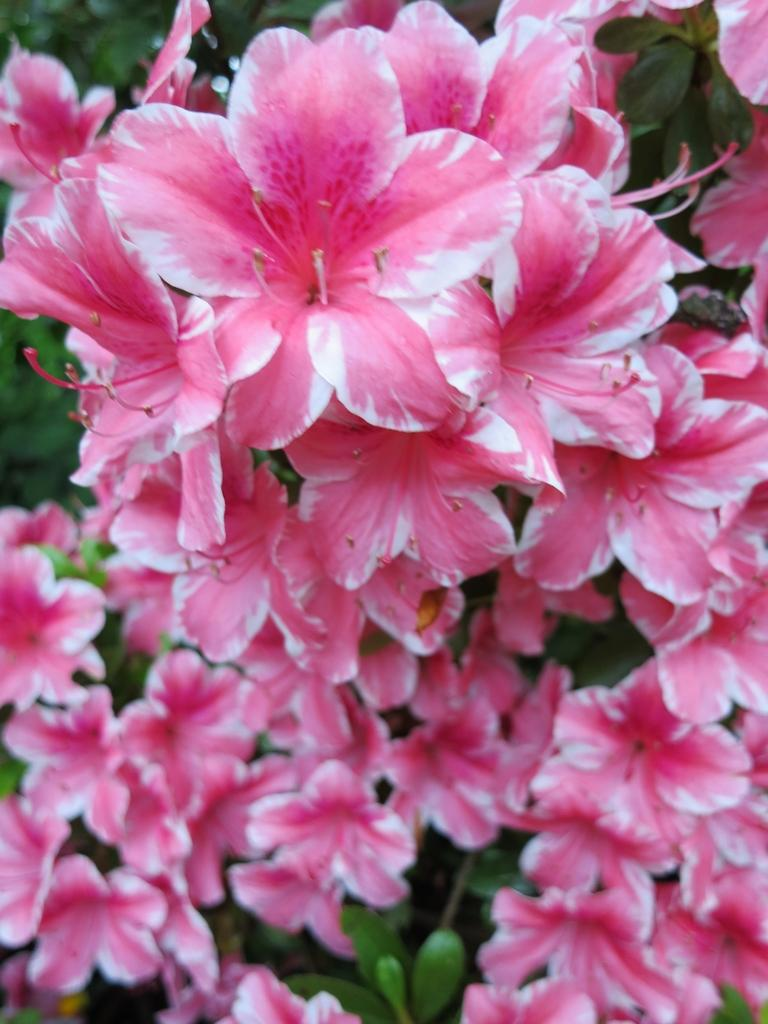What is the main subject of the image? The main subject of the image is a bunch of flowers on a plant. Can you describe the flowers in the image? The flowers are part of a bunch on a plant. What is the setting or context of the image? The image shows flowers on a plant, which suggests a natural or garden setting. What type of advertisement can be seen in the image? There is no advertisement present in the image; it features a bunch of flowers on a plant. Can you describe the motion of the flowers in the image? The flowers are stationary in the image and do not exhibit any motion. 